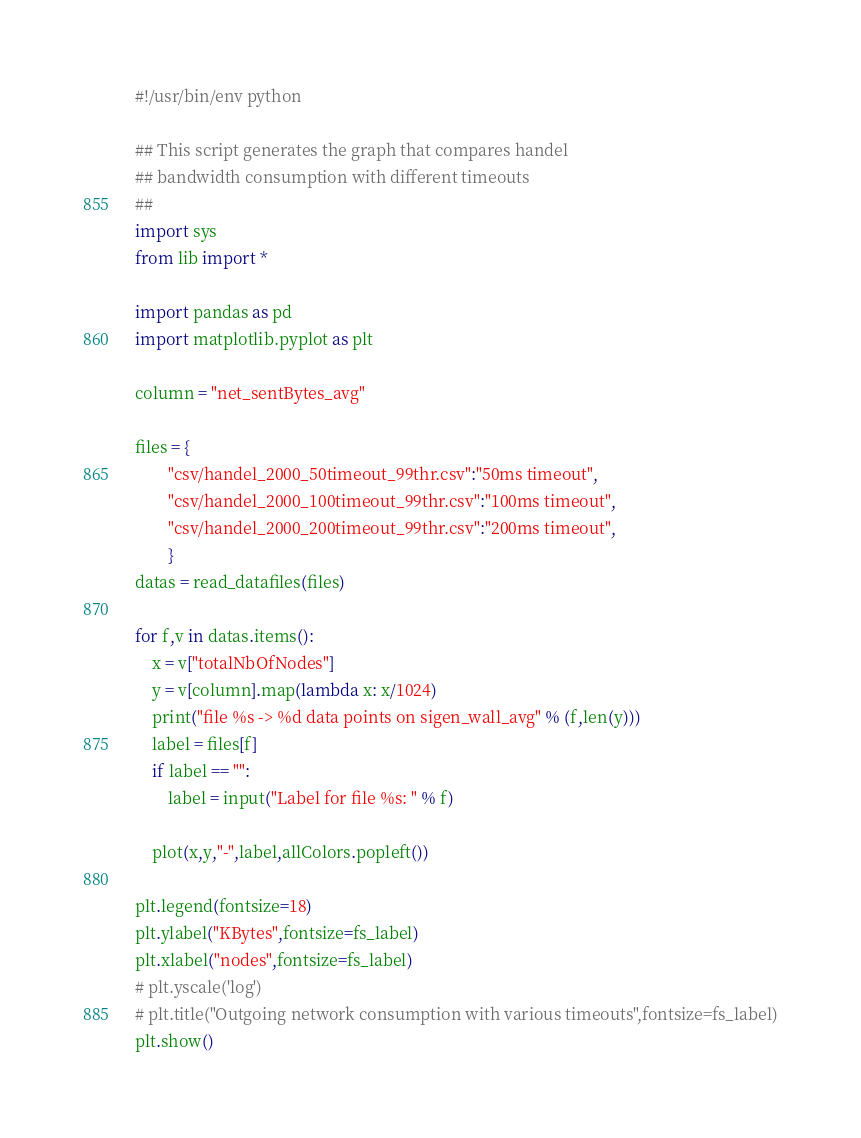Convert code to text. <code><loc_0><loc_0><loc_500><loc_500><_Python_>#!/usr/bin/env python

## This script generates the graph that compares handel 
## bandwidth consumption with different timeouts
##
import sys
from lib import *

import pandas as pd
import matplotlib.pyplot as plt

column = "net_sentBytes_avg"

files = {
        "csv/handel_2000_50timeout_99thr.csv":"50ms timeout",
        "csv/handel_2000_100timeout_99thr.csv":"100ms timeout",
        "csv/handel_2000_200timeout_99thr.csv":"200ms timeout",
        }
datas = read_datafiles(files)

for f,v in datas.items():
    x = v["totalNbOfNodes"]
    y = v[column].map(lambda x: x/1024)
    print("file %s -> %d data points on sigen_wall_avg" % (f,len(y)))
    label = files[f]
    if label == "":
        label = input("Label for file %s: " % f)

    plot(x,y,"-",label,allColors.popleft())

plt.legend(fontsize=18)
plt.ylabel("KBytes",fontsize=fs_label)
plt.xlabel("nodes",fontsize=fs_label)
# plt.yscale('log')
# plt.title("Outgoing network consumption with various timeouts",fontsize=fs_label)
plt.show()
</code> 